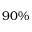<formula> <loc_0><loc_0><loc_500><loc_500>9 0 \%</formula> 